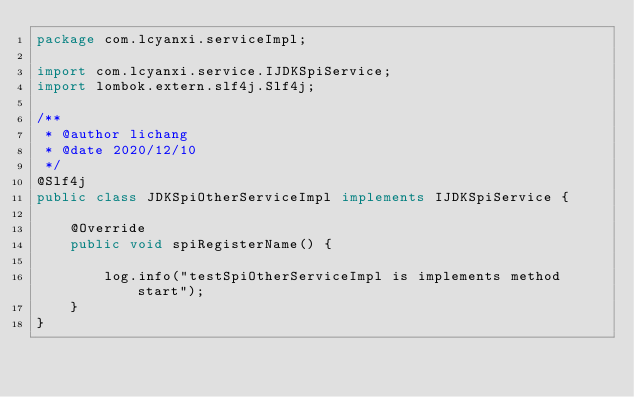Convert code to text. <code><loc_0><loc_0><loc_500><loc_500><_Java_>package com.lcyanxi.serviceImpl;

import com.lcyanxi.service.IJDKSpiService;
import lombok.extern.slf4j.Slf4j;

/**
 * @author lichang
 * @date 2020/12/10
 */
@Slf4j
public class JDKSpiOtherServiceImpl implements IJDKSpiService {

    @Override
    public void spiRegisterName() {

        log.info("testSpiOtherServiceImpl is implements method start");
    }
}
</code> 